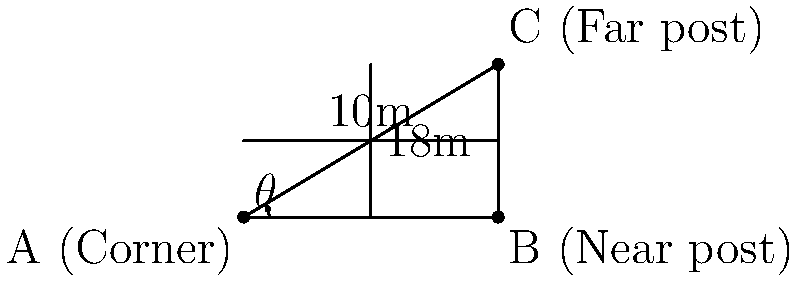During a corner kick, you notice that the angle between the corner flag and the two goalposts forms a right-angled triangle. If the distance from the corner to the near post is 10 meters and the width of the goal is 18 meters, what is the angle $\theta$ between the corner flag and the line connecting the corner to the far post? Let's approach this step-by-step:

1) We have a right-angled triangle where:
   - The base (distance from corner to near post) is 10 meters
   - The height (width of the goal) is 18 meters

2) To find the angle $\theta$, we need to use the arctangent function (atan or tan⁻¹)

3) In a right-angled triangle, tan(θ) = opposite / adjacent
   Here, opposite = 18 and adjacent = 10

4) Therefore, $\theta = \tan^{-1}(\frac{18}{10})$

5) $\theta = \tan^{-1}(1.8)$

6) Using a calculator or math library:
   $\theta \approx 60.95°$

7) Rounding to the nearest degree:
   $\theta \approx 61°$
Answer: $61°$ 